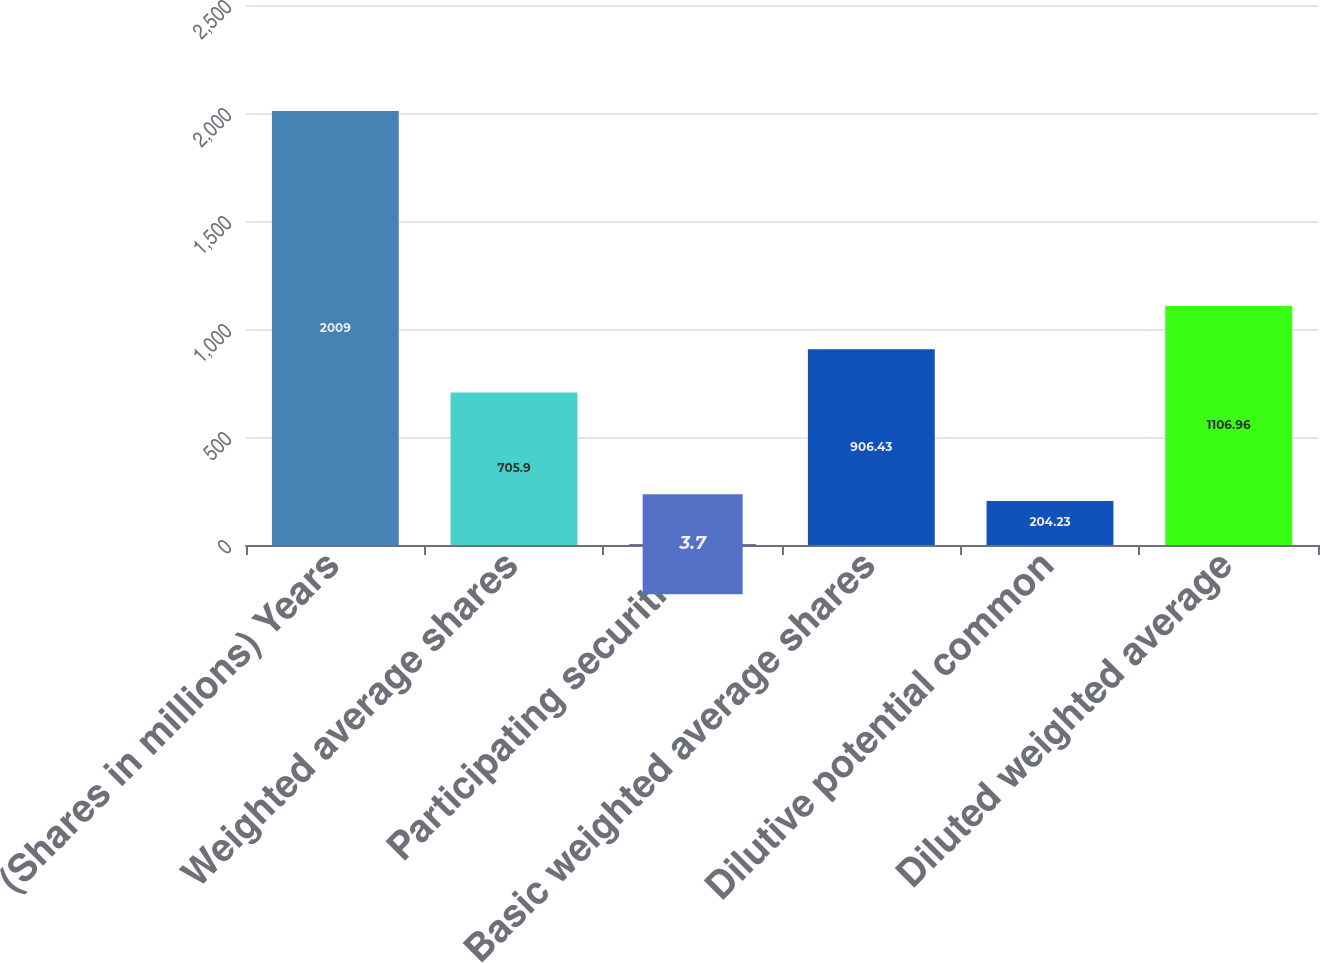<chart> <loc_0><loc_0><loc_500><loc_500><bar_chart><fcel>(Shares in millions) Years<fcel>Weighted average shares<fcel>Participating securities<fcel>Basic weighted average shares<fcel>Dilutive potential common<fcel>Diluted weighted average<nl><fcel>2009<fcel>705.9<fcel>3.7<fcel>906.43<fcel>204.23<fcel>1106.96<nl></chart> 